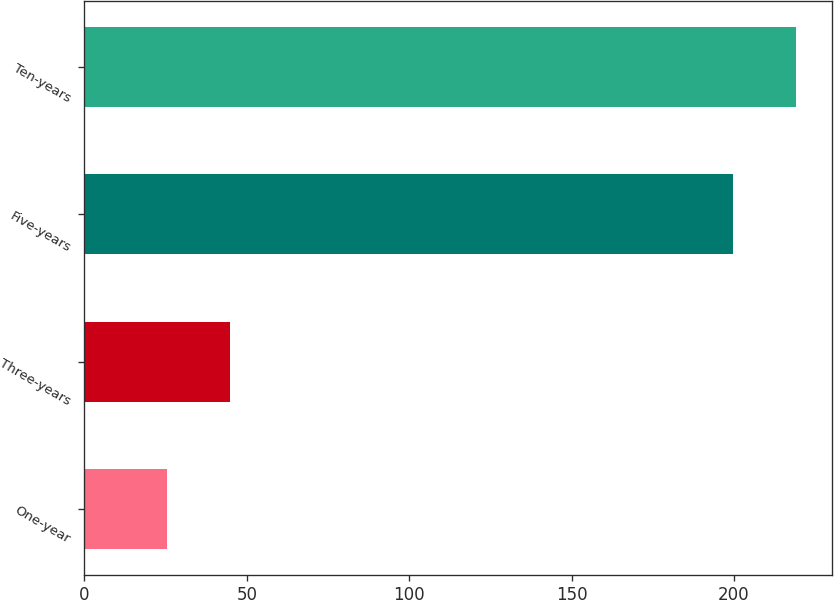Convert chart. <chart><loc_0><loc_0><loc_500><loc_500><bar_chart><fcel>One-year<fcel>Three-years<fcel>Five-years<fcel>Ten-years<nl><fcel>25.5<fcel>44.77<fcel>199.8<fcel>219.07<nl></chart> 